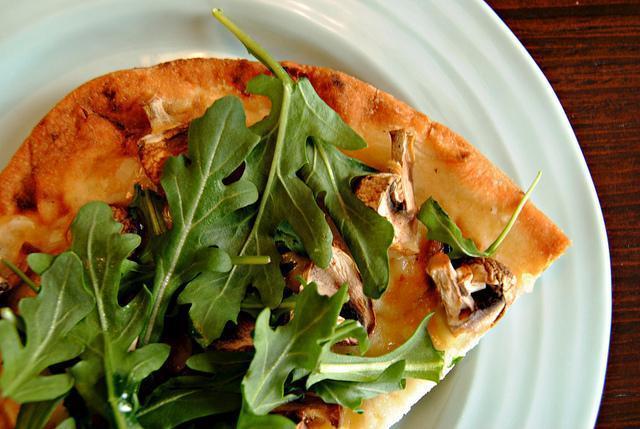How many of the posts ahve clocks on them?
Give a very brief answer. 0. 